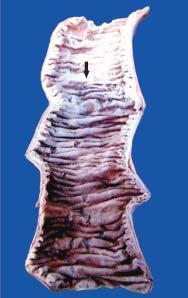what is not clear-cut?
Answer the question using a single word or phrase. Line of demarcation between gangrenous segment and the viable bowel clear-cut 